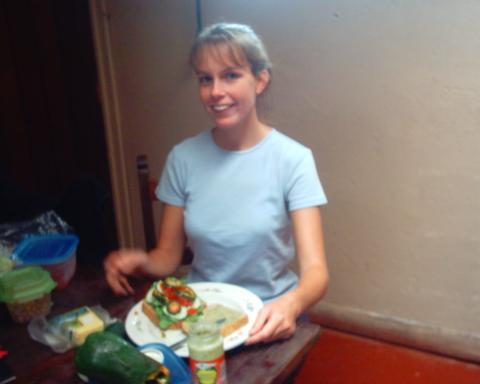How would you describe the type of floor the room has in this image? The room has brown floors. What emotion is the woman showing in the image? The woman is smiling, suggesting happiness or contentment. Count the number of containers with food inside them in the image. There are 3 containers with food inside. What color are the walls in the room as seen in the image? The walls are white. What condiment is in the opened jar on the table? The jar has a white substance in it, likely a spread or sauce. In casual language, what are the ingredients of the sandwich in the image? There are veggies on a slice of bread, making it a veggie sandwich. In poetic language, describe the woman in the image. A lady in a sea of baby blue, amidst a room of white, gazes with a smile, as food fills her sight. What is a clearly identifiable attribute of the woman's shirt in the image? The woman's shirt is light blue in color. Can you spot any green vegetables on the table in this image? Provide a brief description. Yes, there is a green pepper on the table. How many variations of the lady's shirt description are in the image? There are 3 different descriptions of the lady's shirt. 